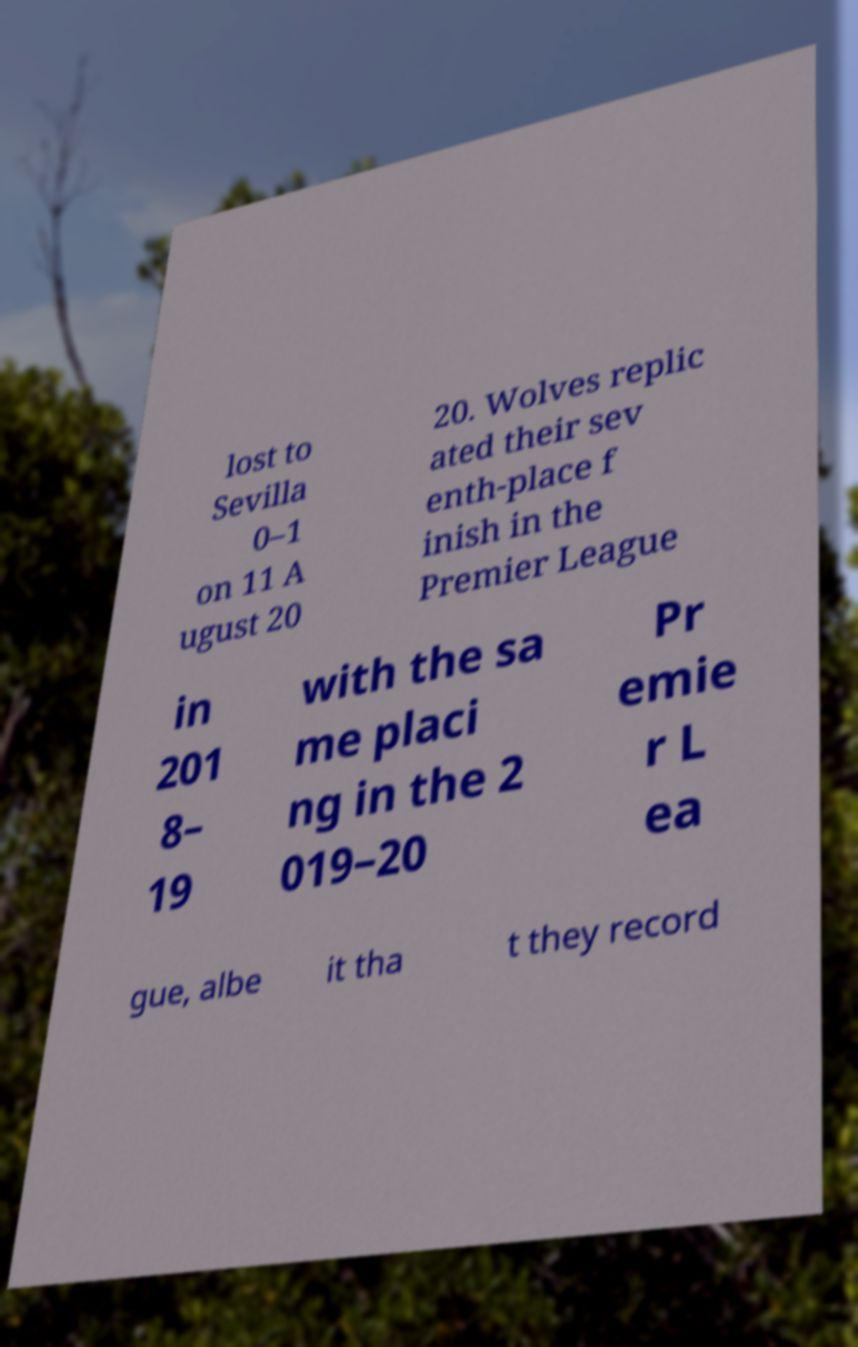For documentation purposes, I need the text within this image transcribed. Could you provide that? lost to Sevilla 0–1 on 11 A ugust 20 20. Wolves replic ated their sev enth-place f inish in the Premier League in 201 8– 19 with the sa me placi ng in the 2 019–20 Pr emie r L ea gue, albe it tha t they record 